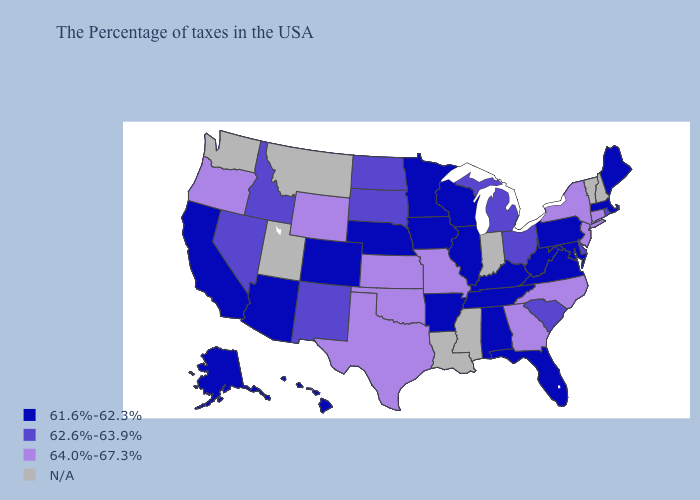What is the value of Delaware?
Keep it brief. 62.6%-63.9%. Does the first symbol in the legend represent the smallest category?
Keep it brief. Yes. What is the value of Mississippi?
Give a very brief answer. N/A. How many symbols are there in the legend?
Short answer required. 4. Among the states that border Connecticut , which have the lowest value?
Write a very short answer. Massachusetts. Name the states that have a value in the range 61.6%-62.3%?
Quick response, please. Maine, Massachusetts, Maryland, Pennsylvania, Virginia, West Virginia, Florida, Kentucky, Alabama, Tennessee, Wisconsin, Illinois, Arkansas, Minnesota, Iowa, Nebraska, Colorado, Arizona, California, Alaska, Hawaii. Among the states that border Ohio , does Michigan have the highest value?
Give a very brief answer. Yes. Does the first symbol in the legend represent the smallest category?
Keep it brief. Yes. Which states hav the highest value in the Northeast?
Quick response, please. Connecticut, New York, New Jersey. Name the states that have a value in the range 61.6%-62.3%?
Be succinct. Maine, Massachusetts, Maryland, Pennsylvania, Virginia, West Virginia, Florida, Kentucky, Alabama, Tennessee, Wisconsin, Illinois, Arkansas, Minnesota, Iowa, Nebraska, Colorado, Arizona, California, Alaska, Hawaii. What is the value of Maine?
Write a very short answer. 61.6%-62.3%. Does the map have missing data?
Give a very brief answer. Yes. Does the first symbol in the legend represent the smallest category?
Be succinct. Yes. 